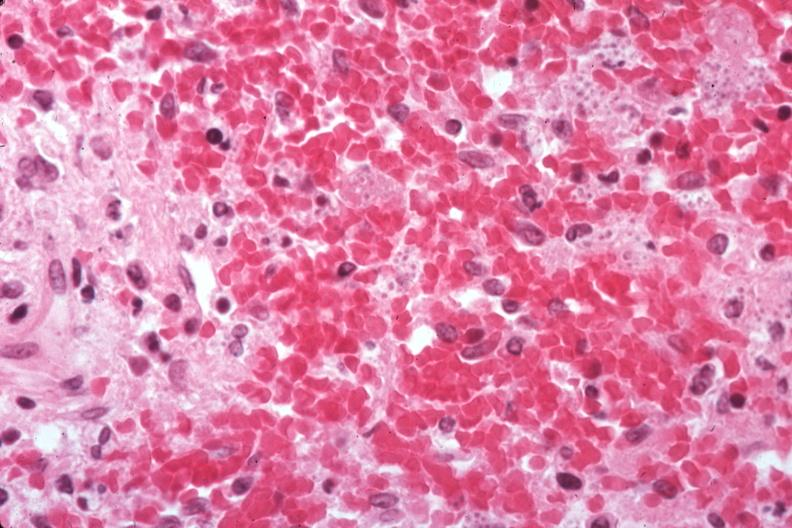what does this image show?
Answer the question using a single word or phrase. Organisms easily seen 